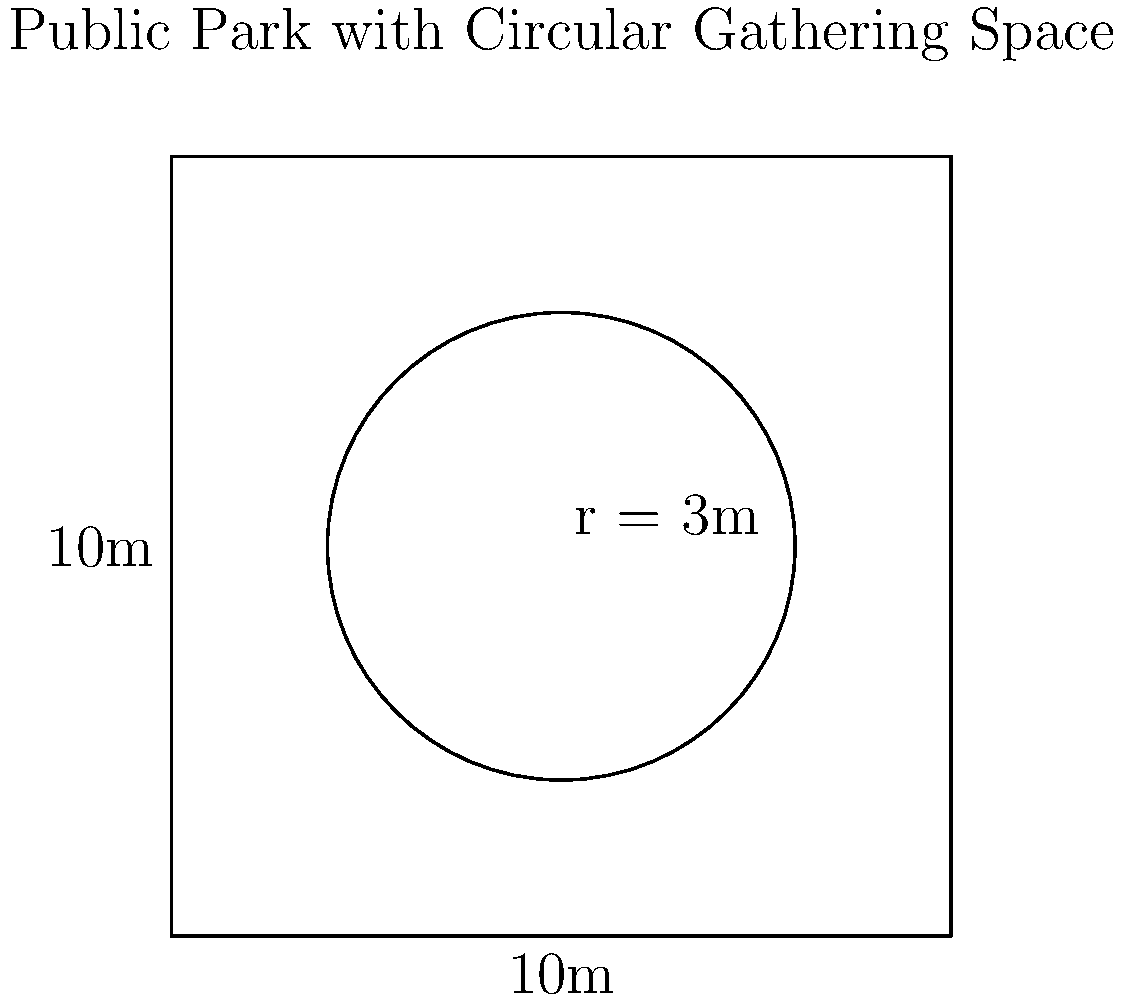A square public park measures 10 meters on each side. The park planner wants to create a circular gathering space in the center of the park. If the radius of the circular space is 3 meters, what percentage of the park's total area will be occupied by the gathering space? Round your answer to the nearest whole percent. To solve this problem, we need to follow these steps:

1. Calculate the area of the square park:
   $A_{square} = side^2 = 10\text{ m} \times 10\text{ m} = 100\text{ m}^2$

2. Calculate the area of the circular gathering space:
   $A_{circle} = \pi r^2 = \pi \times (3\text{ m})^2 = 9\pi\text{ m}^2$

3. Calculate the percentage of the park occupied by the gathering space:
   $\text{Percentage} = \frac{A_{circle}}{A_{square}} \times 100\%$

   $= \frac{9\pi\text{ m}^2}{100\text{ m}^2} \times 100\%$
   
   $= 0.09\pi \times 100\%$
   
   $\approx 28.27\%$

4. Round to the nearest whole percent:
   $28.27\% \approx 28\%$

Therefore, the circular gathering space will occupy approximately 28% of the park's total area.
Answer: 28% 